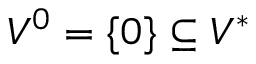<formula> <loc_0><loc_0><loc_500><loc_500>V ^ { 0 } = \{ 0 \} \subseteq V ^ { * }</formula> 